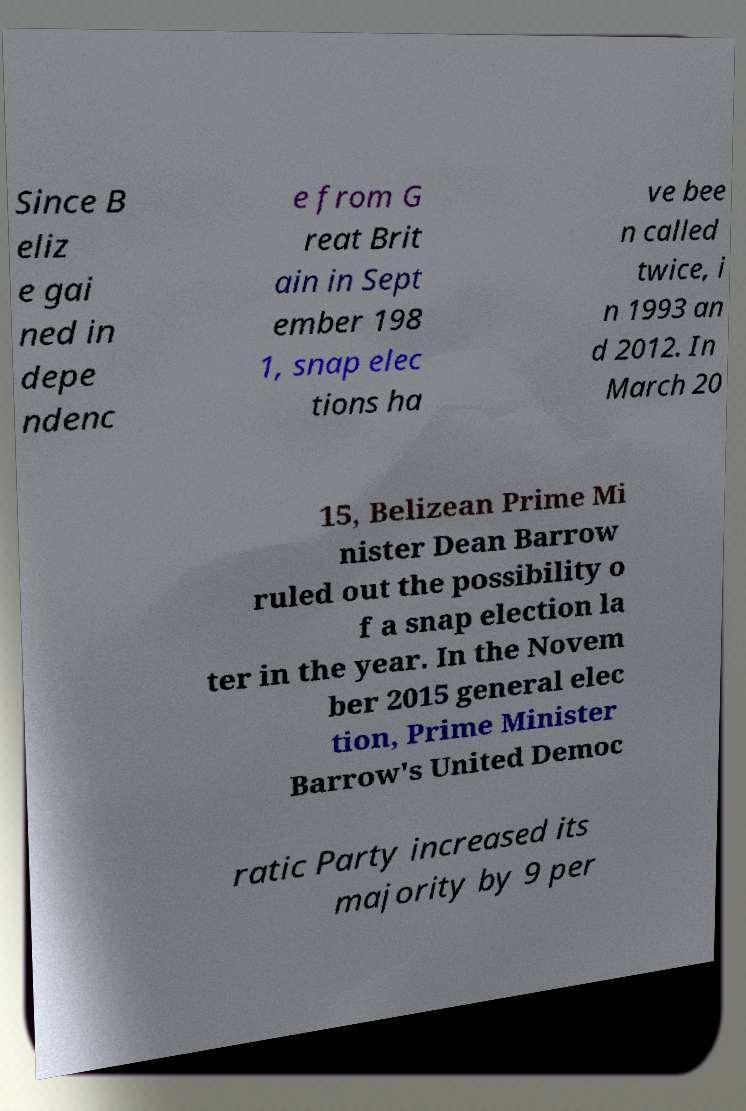Could you assist in decoding the text presented in this image and type it out clearly? Since B eliz e gai ned in depe ndenc e from G reat Brit ain in Sept ember 198 1, snap elec tions ha ve bee n called twice, i n 1993 an d 2012. In March 20 15, Belizean Prime Mi nister Dean Barrow ruled out the possibility o f a snap election la ter in the year. In the Novem ber 2015 general elec tion, Prime Minister Barrow's United Democ ratic Party increased its majority by 9 per 